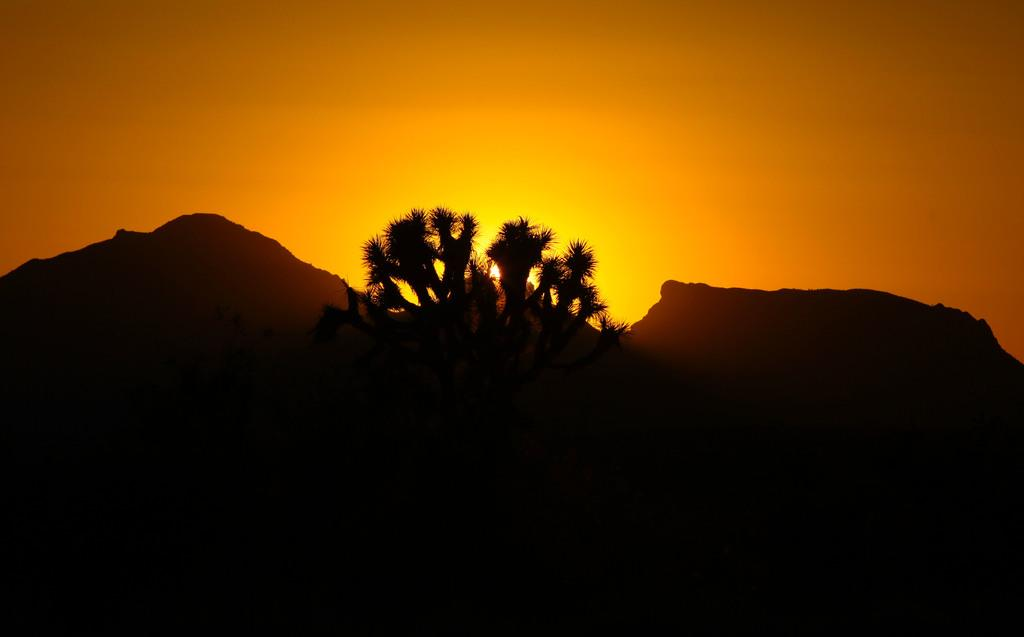What type of natural features can be seen in the image? There are trees and mountains in the image. What celestial body is visible in the background? The sun is visible in the background. What colors are present in the sky in the image? The sky is in orange and yellow color. What type of feather can be seen falling from the sky in the image? There is no feather present in the image; the sky is in orange and yellow color. 